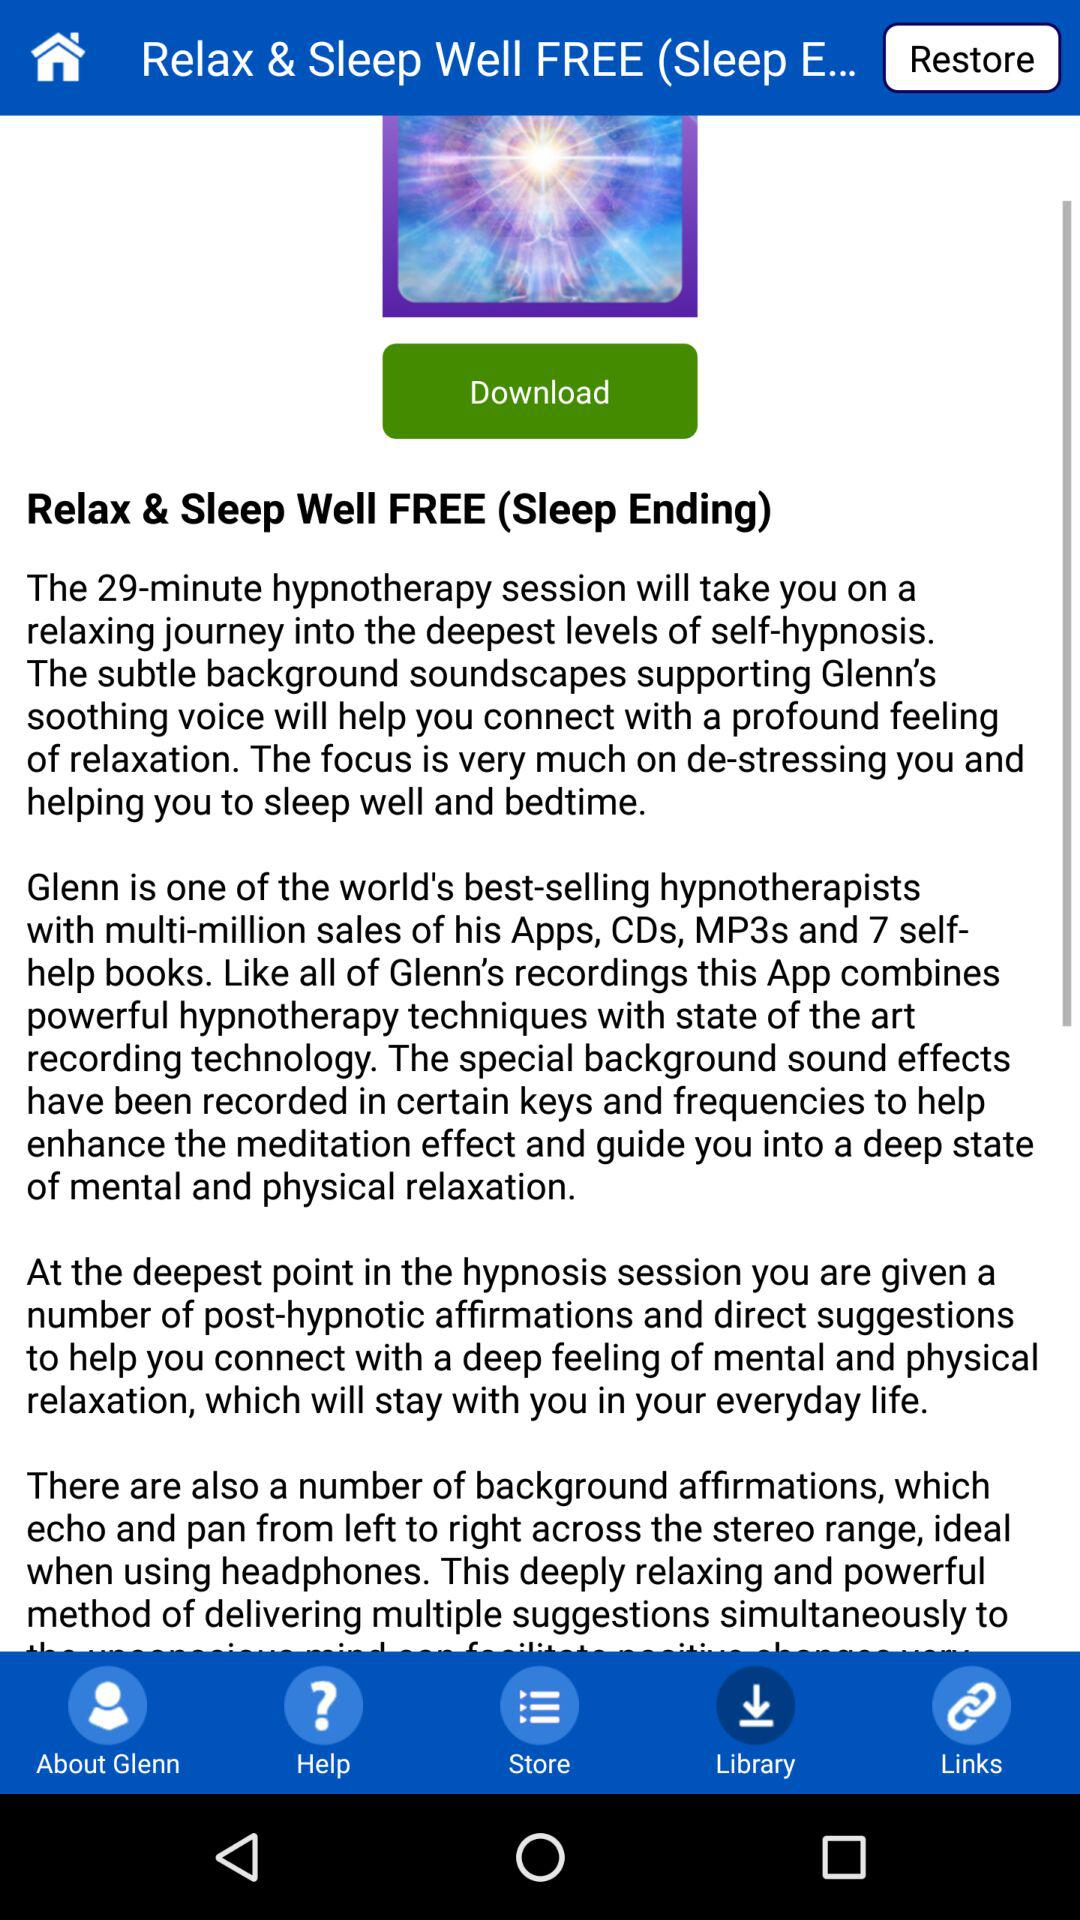Which option is selected? The selected option is "Library". 